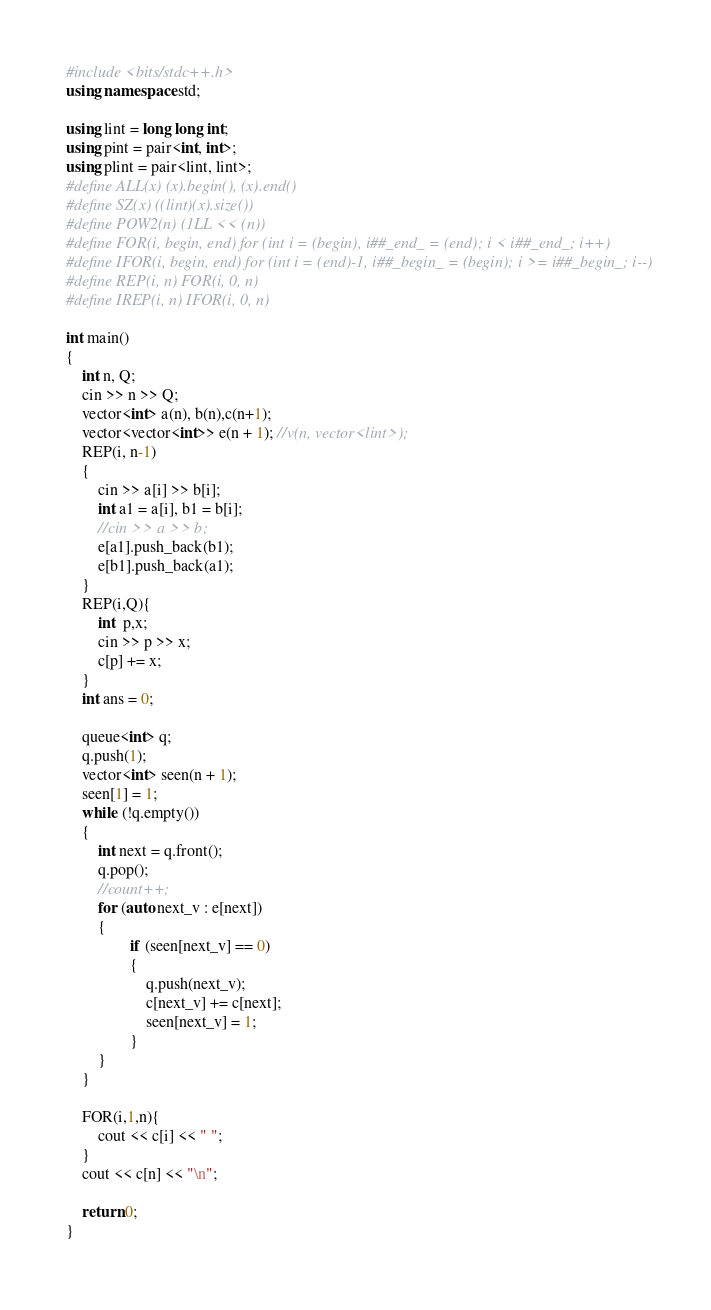Convert code to text. <code><loc_0><loc_0><loc_500><loc_500><_C++_>#include <bits/stdc++.h>
using namespace std;

using lint = long long int;
using pint = pair<int, int>;
using plint = pair<lint, lint>;
#define ALL(x) (x).begin(), (x).end()
#define SZ(x) ((lint)(x).size())
#define POW2(n) (1LL << (n))
#define FOR(i, begin, end) for (int i = (begin), i##_end_ = (end); i < i##_end_; i++)
#define IFOR(i, begin, end) for (int i = (end)-1, i##_begin_ = (begin); i >= i##_begin_; i--)
#define REP(i, n) FOR(i, 0, n)
#define IREP(i, n) IFOR(i, 0, n)

int main()
{
    int n, Q;
    cin >> n >> Q;
    vector<int> a(n), b(n),c(n+1);
    vector<vector<int>> e(n + 1); //v(n, vector<lint>);
    REP(i, n-1)
    {
        cin >> a[i] >> b[i];
        int a1 = a[i], b1 = b[i];
        //cin >> a >> b;
        e[a1].push_back(b1);
        e[b1].push_back(a1);
    }
    REP(i,Q){
        int  p,x;
        cin >> p >> x;
        c[p] += x;
    }
    int ans = 0;

    queue<int> q;
    q.push(1);
    vector<int> seen(n + 1);
    seen[1] = 1;
    while (!q.empty())
    {
        int next = q.front();
        q.pop();
        //count++;
        for (auto next_v : e[next])
        {
                if (seen[next_v] == 0)
                {
                    q.push(next_v);
                    c[next_v] += c[next];
                    seen[next_v] = 1;
                }
        }
    }

    FOR(i,1,n){
        cout << c[i] << " ";
    }
    cout << c[n] << "\n";

    return 0;
}</code> 